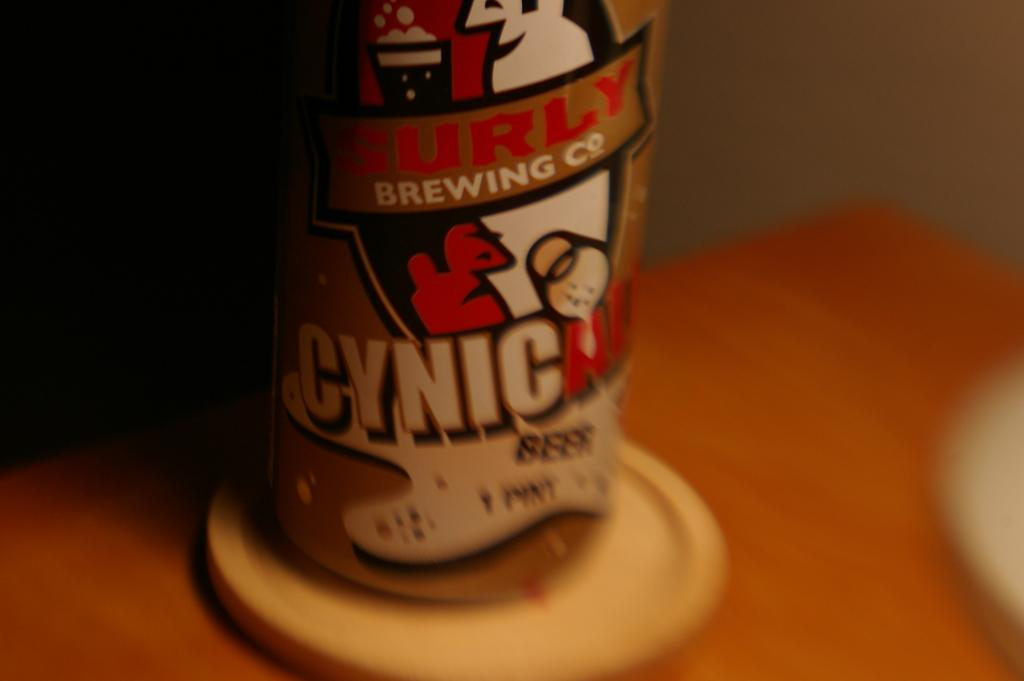<image>
Render a clear and concise summary of the photo. A pint of beer from the Surly Brewing Company. 